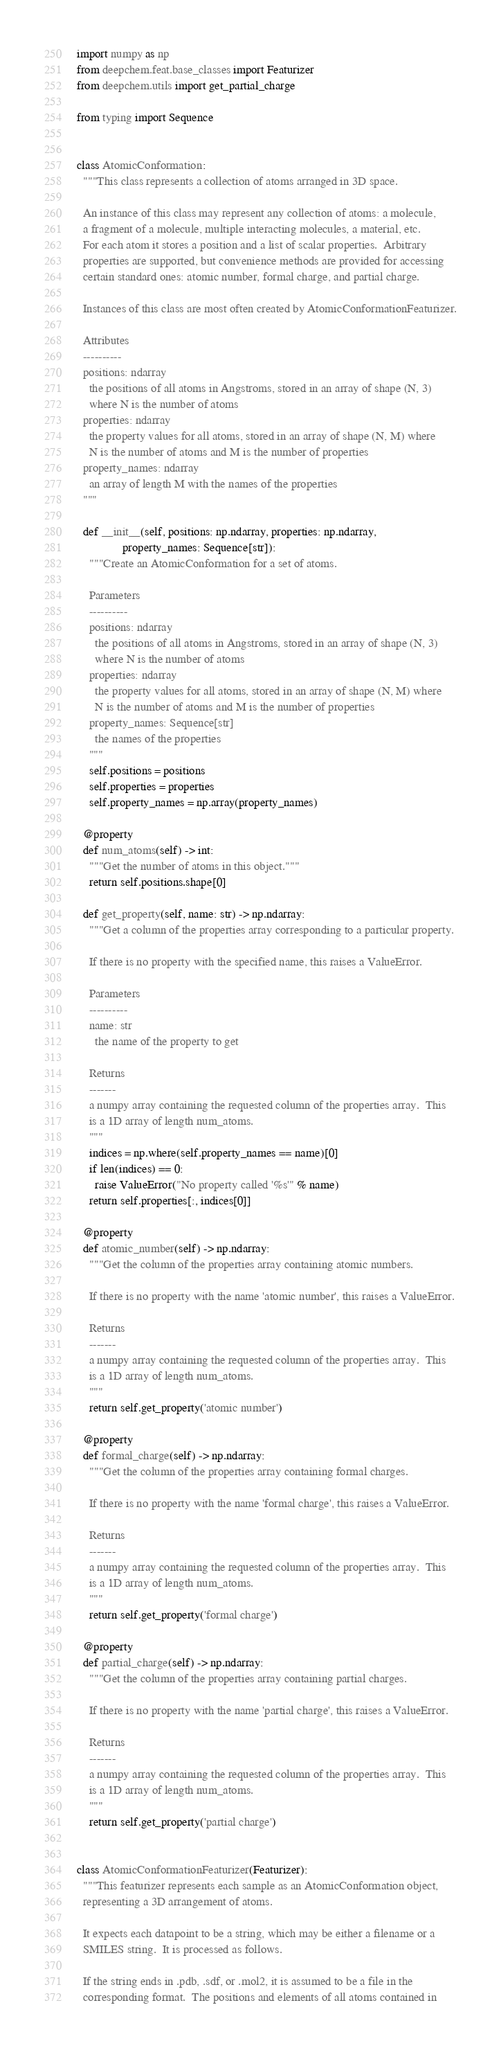<code> <loc_0><loc_0><loc_500><loc_500><_Python_>import numpy as np
from deepchem.feat.base_classes import Featurizer
from deepchem.utils import get_partial_charge

from typing import Sequence


class AtomicConformation:
  """This class represents a collection of atoms arranged in 3D space.

  An instance of this class may represent any collection of atoms: a molecule,
  a fragment of a molecule, multiple interacting molecules, a material, etc.
  For each atom it stores a position and a list of scalar properties.  Arbitrary
  properties are supported, but convenience methods are provided for accessing
  certain standard ones: atomic number, formal charge, and partial charge.

  Instances of this class are most often created by AtomicConformationFeaturizer.

  Attributes
  ----------
  positions: ndarray
    the positions of all atoms in Angstroms, stored in an array of shape (N, 3)
    where N is the number of atoms
  properties: ndarray
    the property values for all atoms, stored in an array of shape (N, M) where
    N is the number of atoms and M is the number of properties
  property_names: ndarray
    an array of length M with the names of the properties
  """

  def __init__(self, positions: np.ndarray, properties: np.ndarray,
               property_names: Sequence[str]):
    """Create an AtomicConformation for a set of atoms.

    Parameters
    ----------
    positions: ndarray
      the positions of all atoms in Angstroms, stored in an array of shape (N, 3)
      where N is the number of atoms
    properties: ndarray
      the property values for all atoms, stored in an array of shape (N, M) where
      N is the number of atoms and M is the number of properties
    property_names: Sequence[str]
      the names of the properties
    """
    self.positions = positions
    self.properties = properties
    self.property_names = np.array(property_names)

  @property
  def num_atoms(self) -> int:
    """Get the number of atoms in this object."""
    return self.positions.shape[0]

  def get_property(self, name: str) -> np.ndarray:
    """Get a column of the properties array corresponding to a particular property.

    If there is no property with the specified name, this raises a ValueError.

    Parameters
    ----------
    name: str
      the name of the property to get

    Returns
    -------
    a numpy array containing the requested column of the properties array.  This
    is a 1D array of length num_atoms.
    """
    indices = np.where(self.property_names == name)[0]
    if len(indices) == 0:
      raise ValueError("No property called '%s'" % name)
    return self.properties[:, indices[0]]

  @property
  def atomic_number(self) -> np.ndarray:
    """Get the column of the properties array containing atomic numbers.

    If there is no property with the name 'atomic number', this raises a ValueError.

    Returns
    -------
    a numpy array containing the requested column of the properties array.  This
    is a 1D array of length num_atoms.
    """
    return self.get_property('atomic number')

  @property
  def formal_charge(self) -> np.ndarray:
    """Get the column of the properties array containing formal charges.

    If there is no property with the name 'formal charge', this raises a ValueError.

    Returns
    -------
    a numpy array containing the requested column of the properties array.  This
    is a 1D array of length num_atoms.
    """
    return self.get_property('formal charge')

  @property
  def partial_charge(self) -> np.ndarray:
    """Get the column of the properties array containing partial charges.

    If there is no property with the name 'partial charge', this raises a ValueError.

    Returns
    -------
    a numpy array containing the requested column of the properties array.  This
    is a 1D array of length num_atoms.
    """
    return self.get_property('partial charge')


class AtomicConformationFeaturizer(Featurizer):
  """This featurizer represents each sample as an AtomicConformation object,
  representing a 3D arrangement of atoms.

  It expects each datapoint to be a string, which may be either a filename or a
  SMILES string.  It is processed as follows.

  If the string ends in .pdb, .sdf, or .mol2, it is assumed to be a file in the
  corresponding format.  The positions and elements of all atoms contained in</code> 